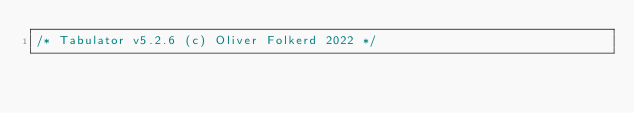Convert code to text. <code><loc_0><loc_0><loc_500><loc_500><_JavaScript_>/* Tabulator v5.2.6 (c) Oliver Folkerd 2022 */</code> 